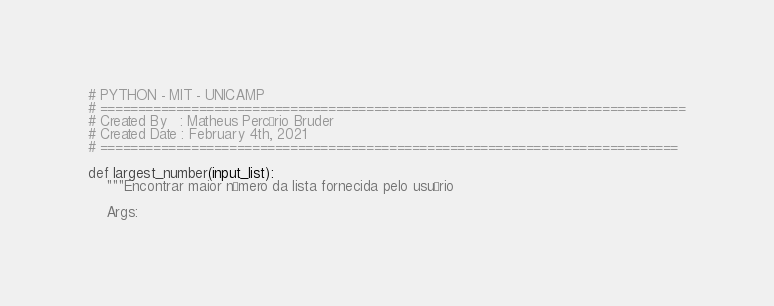<code> <loc_0><loc_0><loc_500><loc_500><_Python_># PYTHON - MIT - UNICAMP
# =============================================================================
# Created By   : Matheus Percário Bruder
# Created Date : February 4th, 2021
# ============================================================================

def largest_number(input_list):
    """Encontrar maior número da lista fornecida pelo usuário

    Args:</code> 